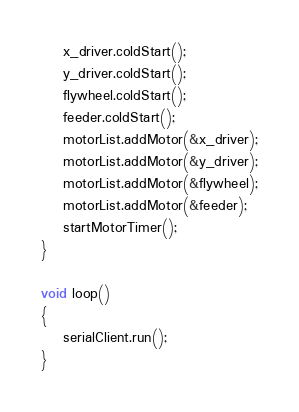<code> <loc_0><loc_0><loc_500><loc_500><_C++_>    x_driver.coldStart();
    y_driver.coldStart();
    flywheel.coldStart();
    feeder.coldStart();
    motorList.addMotor(&x_driver);
    motorList.addMotor(&y_driver);
    motorList.addMotor(&flywheel);
    motorList.addMotor(&feeder);
    startMotorTimer();
}

void loop()
{
    serialClient.run();
}
</code> 